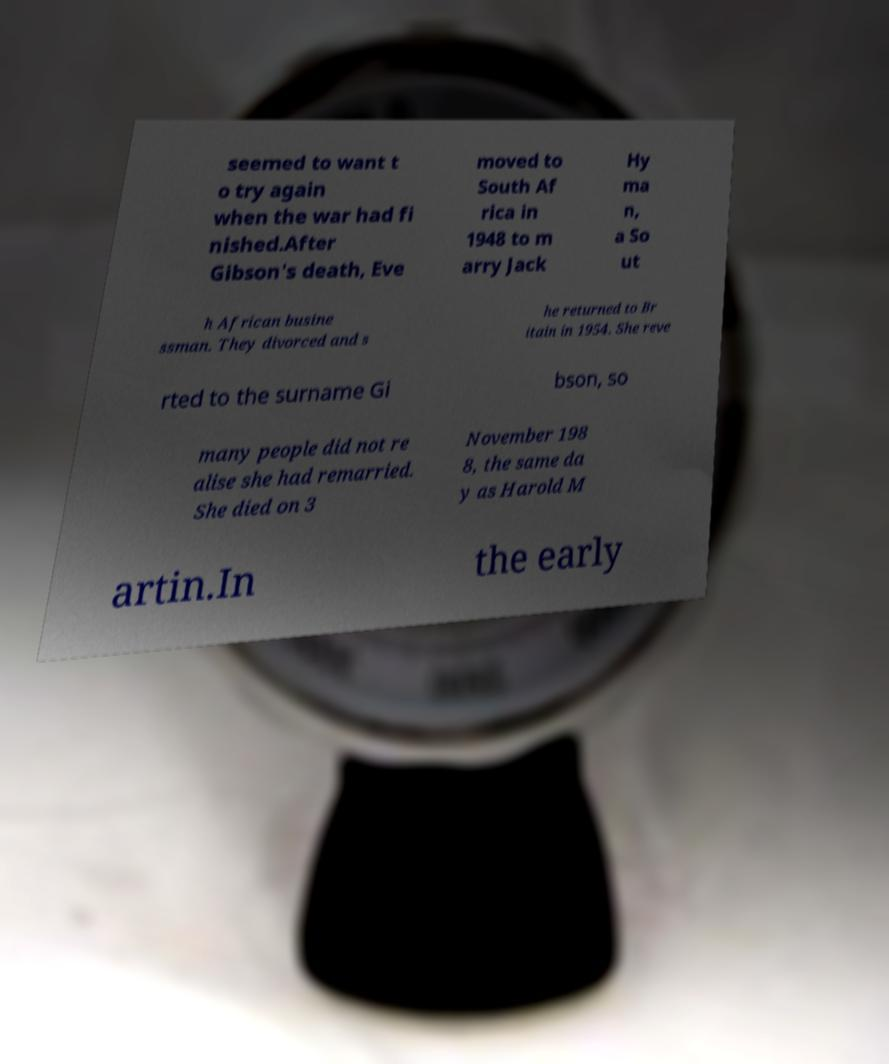Could you assist in decoding the text presented in this image and type it out clearly? seemed to want t o try again when the war had fi nished.After Gibson's death, Eve moved to South Af rica in 1948 to m arry Jack Hy ma n, a So ut h African busine ssman. They divorced and s he returned to Br itain in 1954. She reve rted to the surname Gi bson, so many people did not re alise she had remarried. She died on 3 November 198 8, the same da y as Harold M artin.In the early 